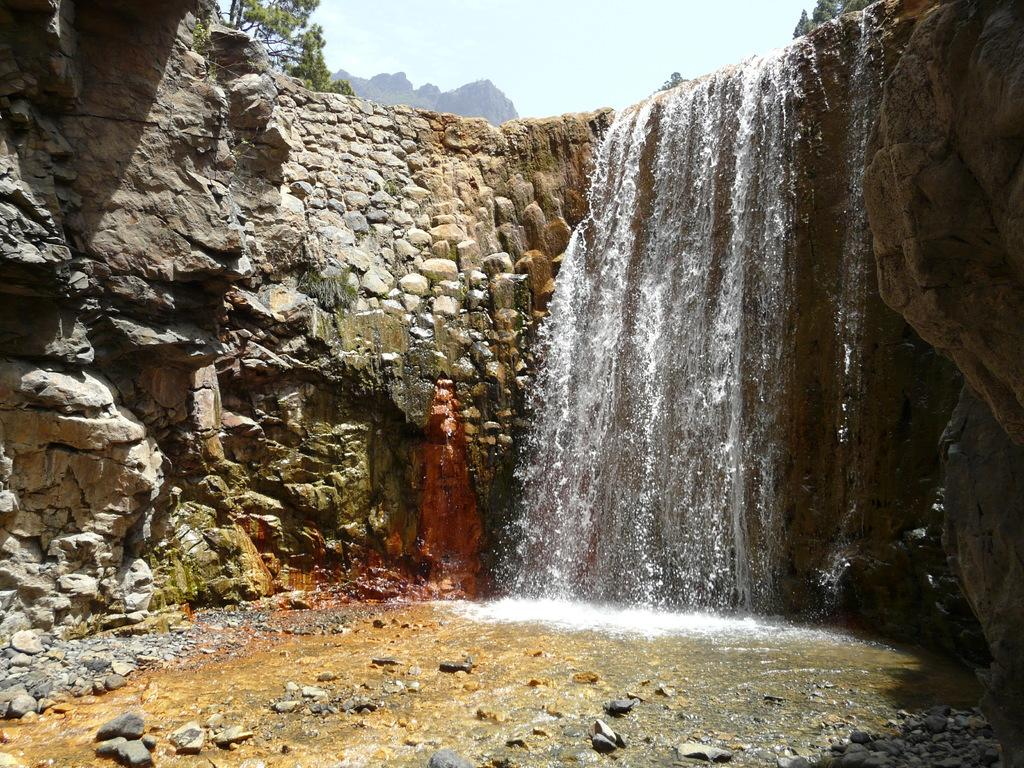What natural feature is the main subject of the image? There is a waterfall in the image. What type of objects can be seen near the waterfall? There are stones in the image. What type of vegetation is present in the image? There are trees in the image. What type of landscape feature can be seen in the image? There are hills in the image. What is visible in the background of the image? The sky is visible in the background of the image. What type of butter is being spread on the hill in the image? There is no butter present in the image; it is a natural landscape featuring a waterfall, stones, trees, hills, and the sky. 